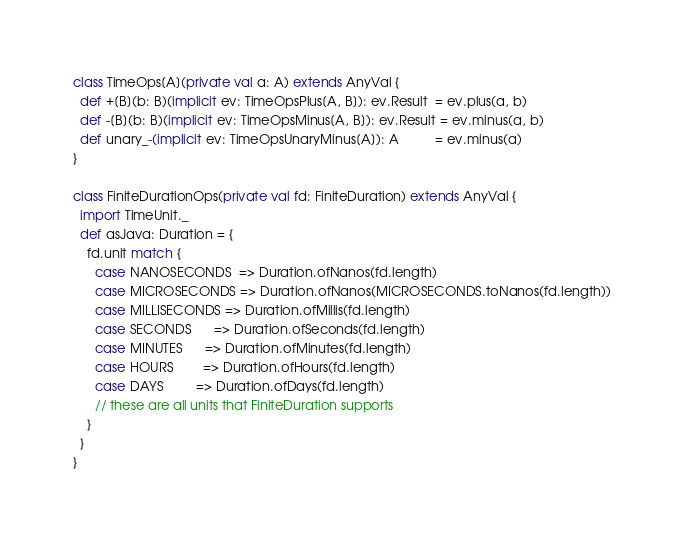<code> <loc_0><loc_0><loc_500><loc_500><_Scala_>
class TimeOps[A](private val a: A) extends AnyVal {
  def +[B](b: B)(implicit ev: TimeOpsPlus[A, B]): ev.Result  = ev.plus(a, b)
  def -[B](b: B)(implicit ev: TimeOpsMinus[A, B]): ev.Result = ev.minus(a, b)
  def unary_-(implicit ev: TimeOpsUnaryMinus[A]): A          = ev.minus(a)
}

class FiniteDurationOps(private val fd: FiniteDuration) extends AnyVal {
  import TimeUnit._
  def asJava: Duration = {
    fd.unit match {
      case NANOSECONDS  => Duration.ofNanos(fd.length)
      case MICROSECONDS => Duration.ofNanos(MICROSECONDS.toNanos(fd.length))
      case MILLISECONDS => Duration.ofMillis(fd.length)
      case SECONDS      => Duration.ofSeconds(fd.length)
      case MINUTES      => Duration.ofMinutes(fd.length)
      case HOURS        => Duration.ofHours(fd.length)
      case DAYS         => Duration.ofDays(fd.length)
      // these are all units that FiniteDuration supports
    }
  }
}
</code> 